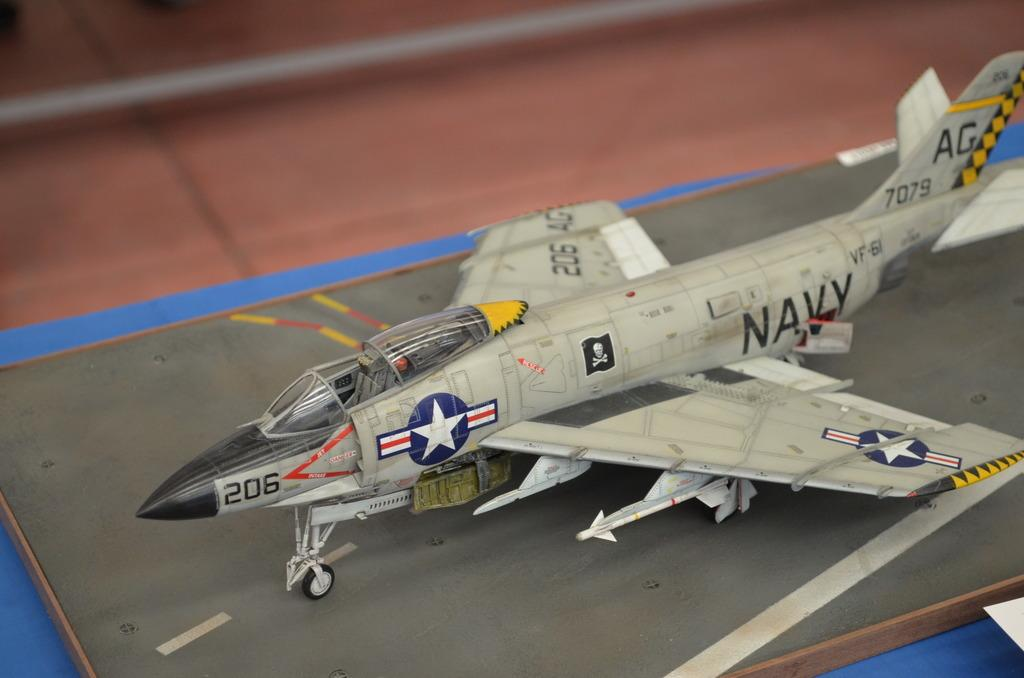<image>
Provide a brief description of the given image. A model of a Navy jet is decorated with stickers and the number 206. 